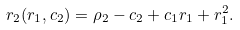Convert formula to latex. <formula><loc_0><loc_0><loc_500><loc_500>r _ { 2 } ( r _ { 1 } , c _ { 2 } ) = \rho _ { 2 } - c _ { 2 } + c _ { 1 } r _ { 1 } + r _ { 1 } ^ { 2 } .</formula> 